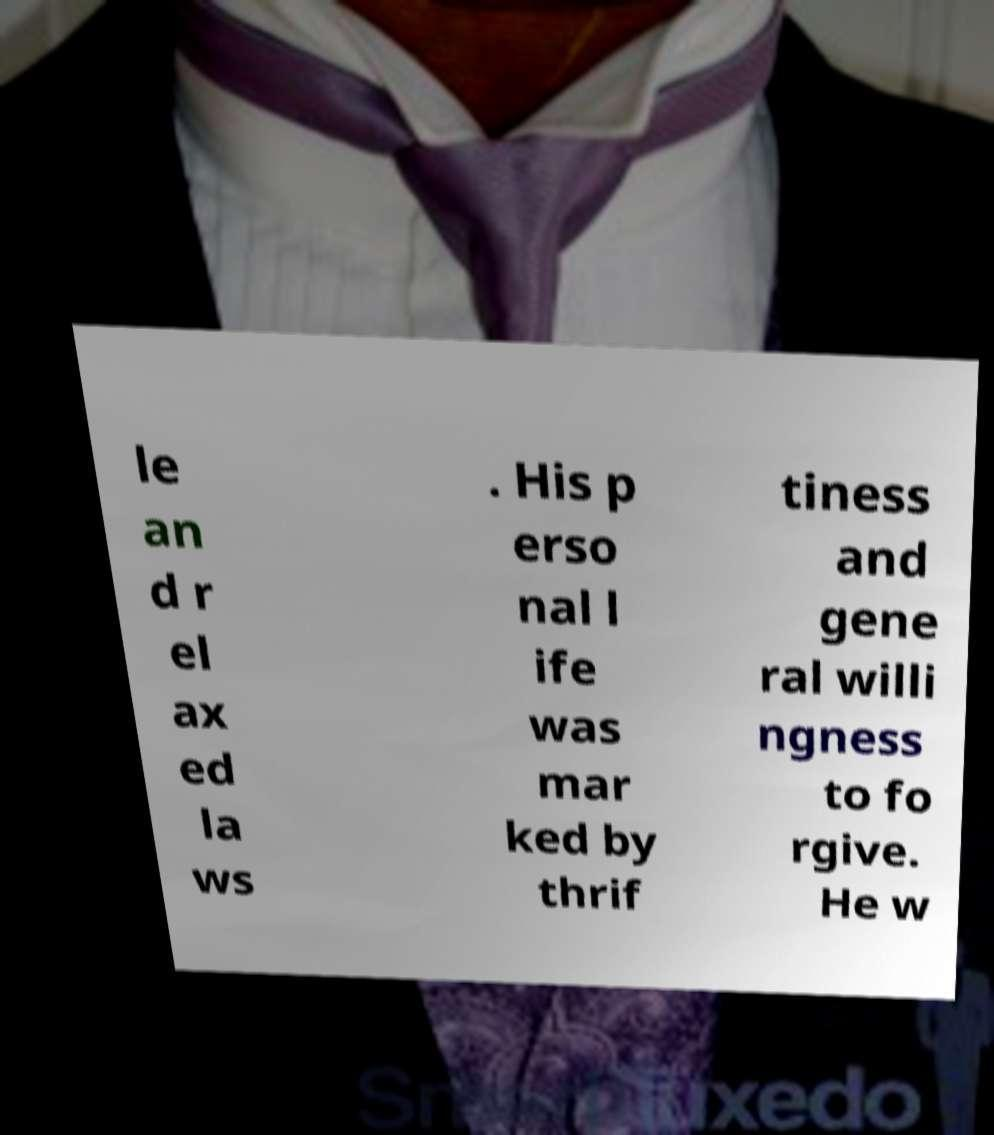For documentation purposes, I need the text within this image transcribed. Could you provide that? le an d r el ax ed la ws . His p erso nal l ife was mar ked by thrif tiness and gene ral willi ngness to fo rgive. He w 